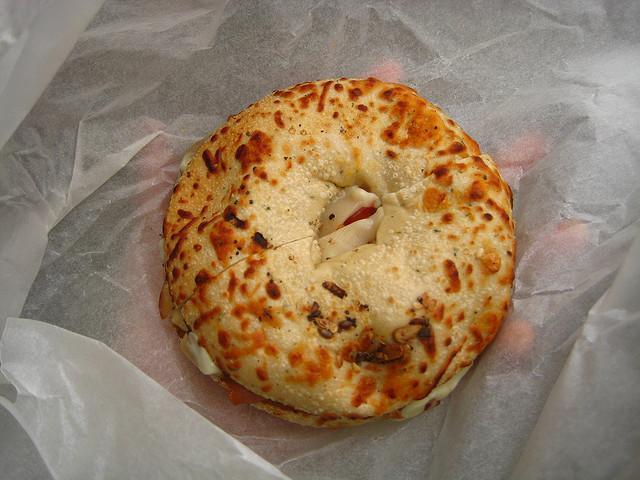How many tags in the cows ears?
Give a very brief answer. 0. 